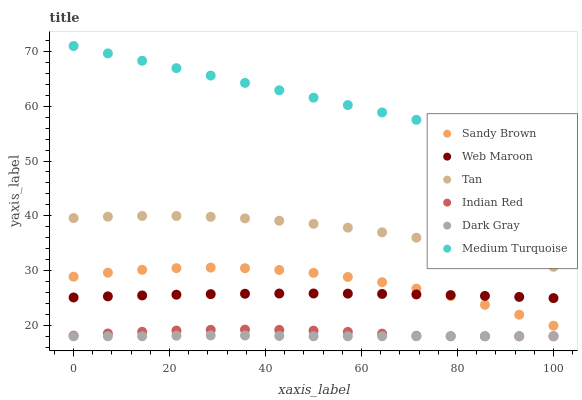Does Dark Gray have the minimum area under the curve?
Answer yes or no. Yes. Does Medium Turquoise have the maximum area under the curve?
Answer yes or no. Yes. Does Web Maroon have the minimum area under the curve?
Answer yes or no. No. Does Web Maroon have the maximum area under the curve?
Answer yes or no. No. Is Medium Turquoise the smoothest?
Answer yes or no. Yes. Is Sandy Brown the roughest?
Answer yes or no. Yes. Is Web Maroon the smoothest?
Answer yes or no. No. Is Web Maroon the roughest?
Answer yes or no. No. Does Indian Red have the lowest value?
Answer yes or no. Yes. Does Web Maroon have the lowest value?
Answer yes or no. No. Does Medium Turquoise have the highest value?
Answer yes or no. Yes. Does Web Maroon have the highest value?
Answer yes or no. No. Is Dark Gray less than Sandy Brown?
Answer yes or no. Yes. Is Medium Turquoise greater than Tan?
Answer yes or no. Yes. Does Sandy Brown intersect Web Maroon?
Answer yes or no. Yes. Is Sandy Brown less than Web Maroon?
Answer yes or no. No. Is Sandy Brown greater than Web Maroon?
Answer yes or no. No. Does Dark Gray intersect Sandy Brown?
Answer yes or no. No. 